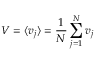<formula> <loc_0><loc_0><loc_500><loc_500>V = \langle v _ { j } \rangle = \frac { 1 } { N } \sum _ { j = 1 } ^ { N } v _ { j }</formula> 